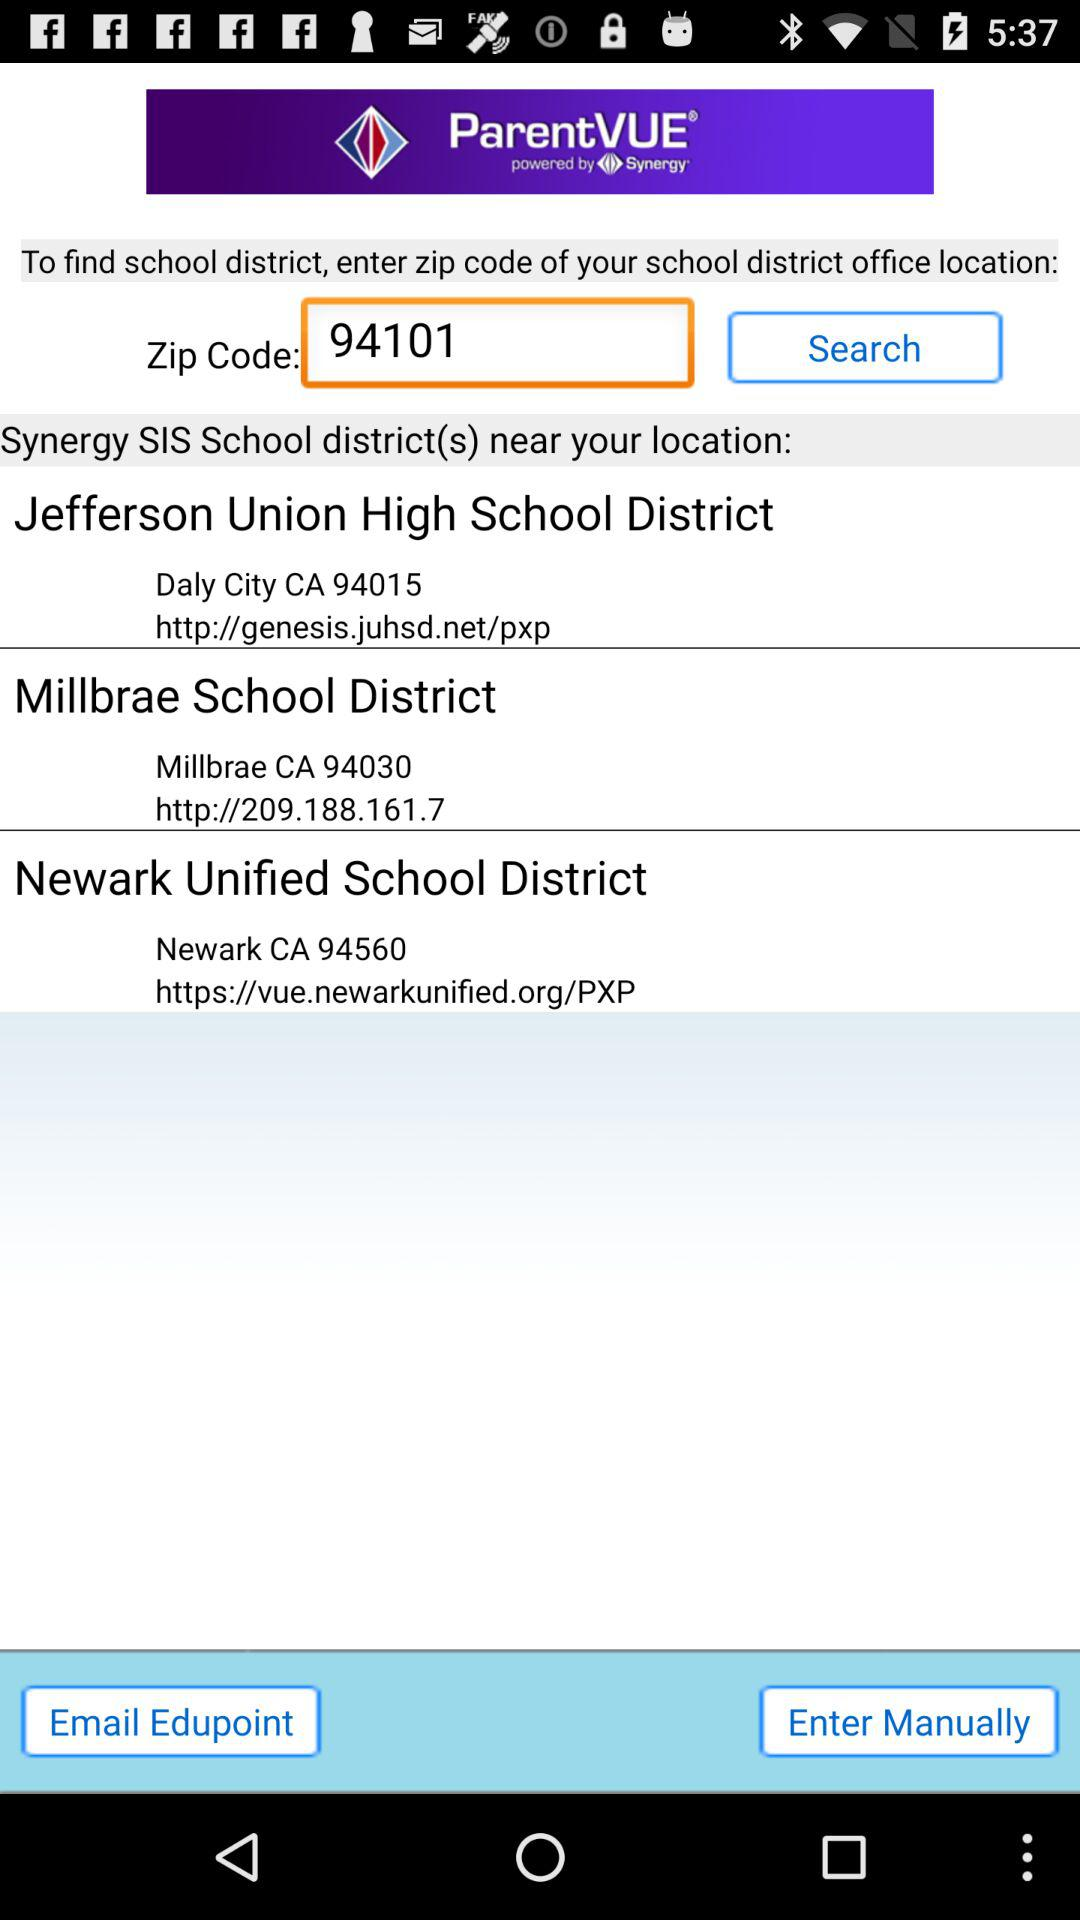What is the address of the "Jefferson Union High School District"? The address is "Daly City CA 94015". 